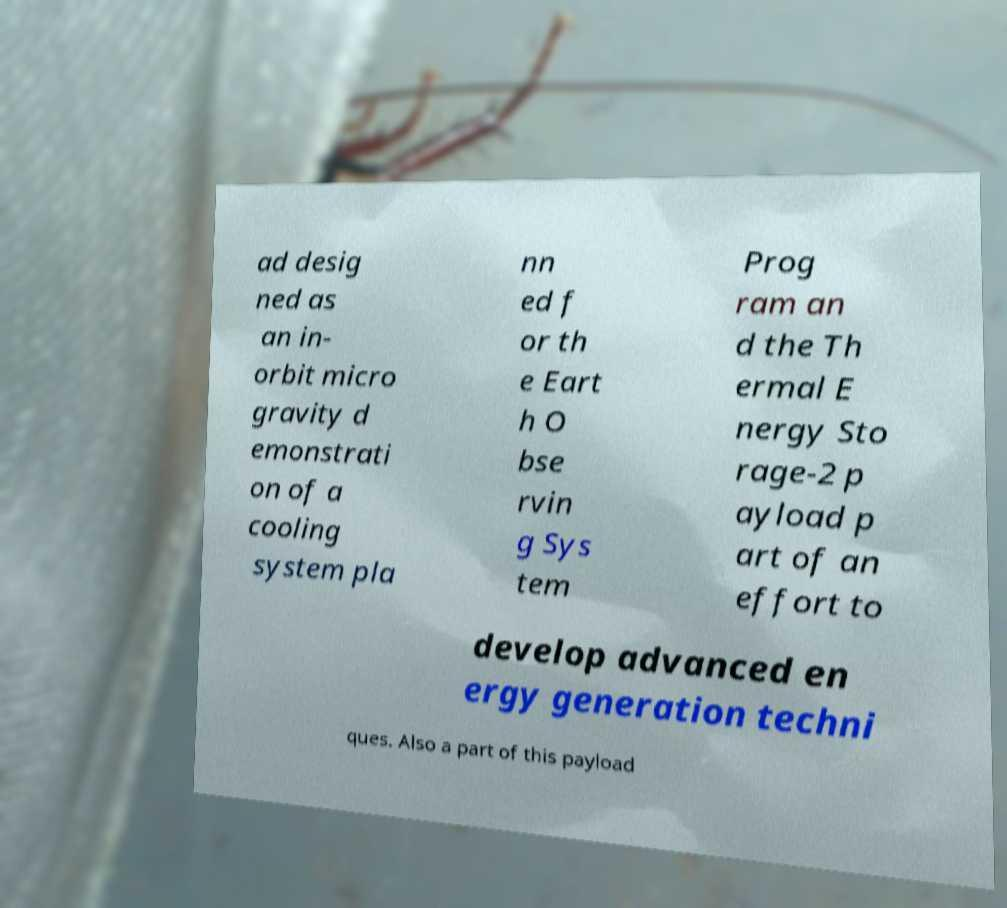Please identify and transcribe the text found in this image. ad desig ned as an in- orbit micro gravity d emonstrati on of a cooling system pla nn ed f or th e Eart h O bse rvin g Sys tem Prog ram an d the Th ermal E nergy Sto rage-2 p ayload p art of an effort to develop advanced en ergy generation techni ques. Also a part of this payload 